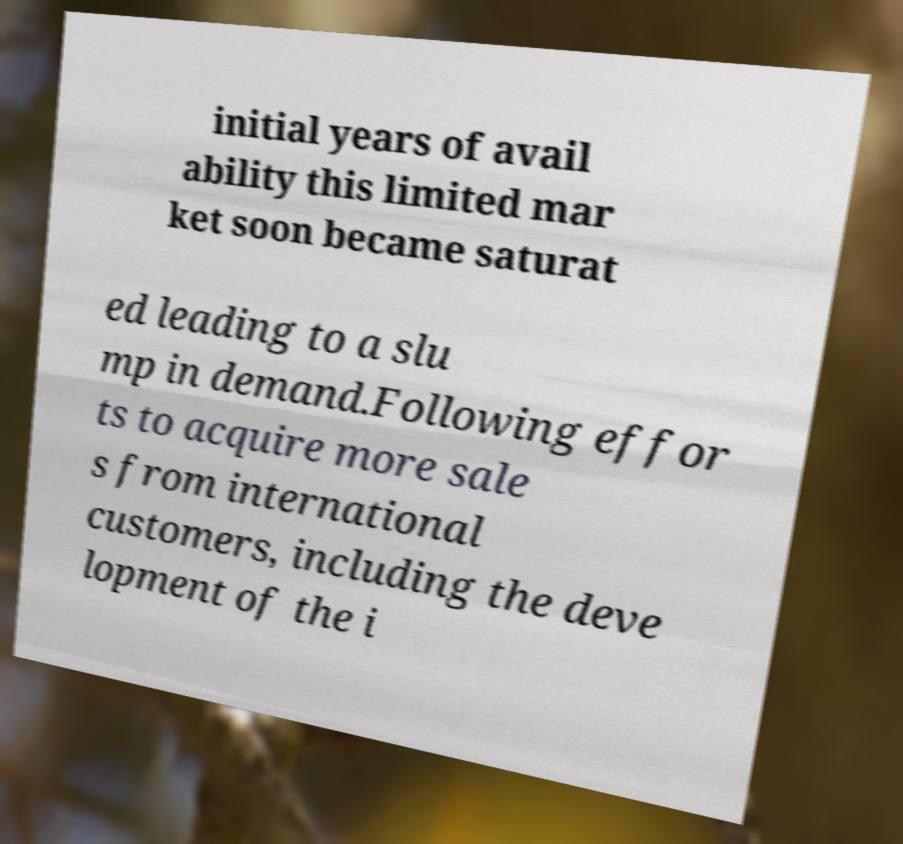Can you accurately transcribe the text from the provided image for me? initial years of avail ability this limited mar ket soon became saturat ed leading to a slu mp in demand.Following effor ts to acquire more sale s from international customers, including the deve lopment of the i 